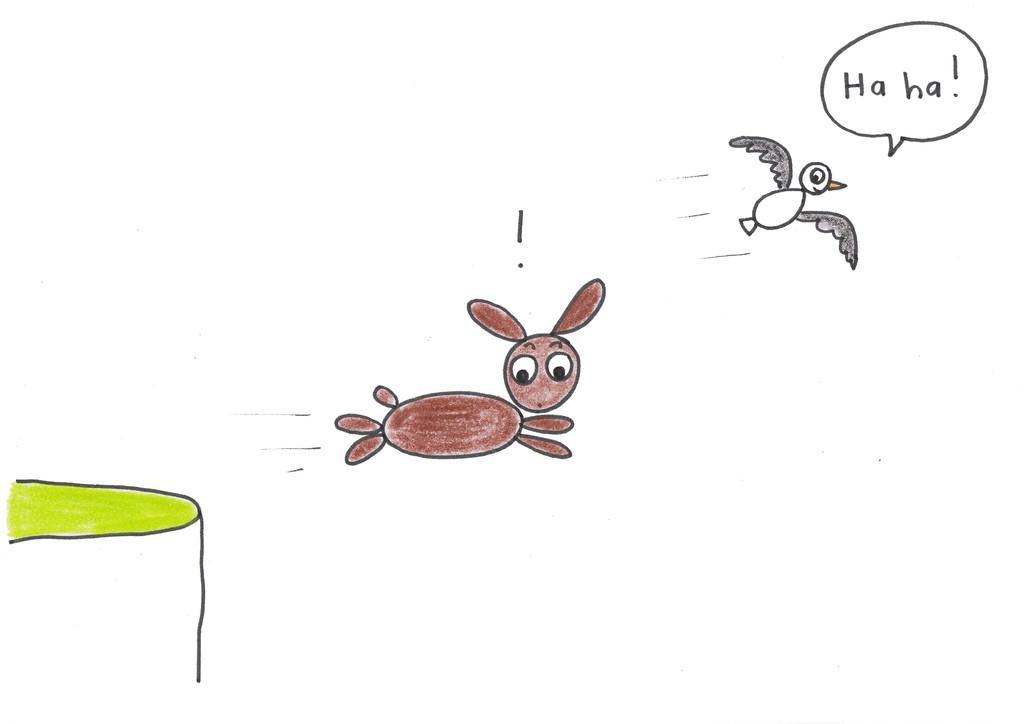How would you summarize this image in a sentence or two? This is a picture of the drawing in this picture there is one rabbit, bird and grass. 